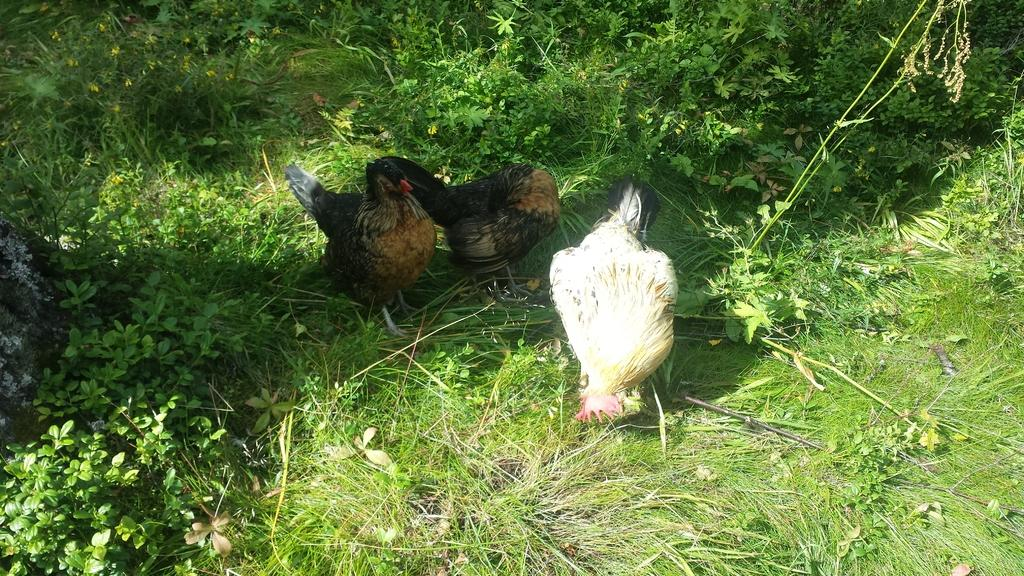What type of surface is visible in the image? There is a grass surface in the image. What can be found on the grass surface? There are plants on the grass surface. How many hands are visible in the image? There are three hands in the image. How many hens are present, and what are their colors? One hen is white, and the other two hens are brown with some black color. What type of stamp can be seen on the white hen's feathers? There is no stamp present on the white hen's feathers or any other part of the image. 